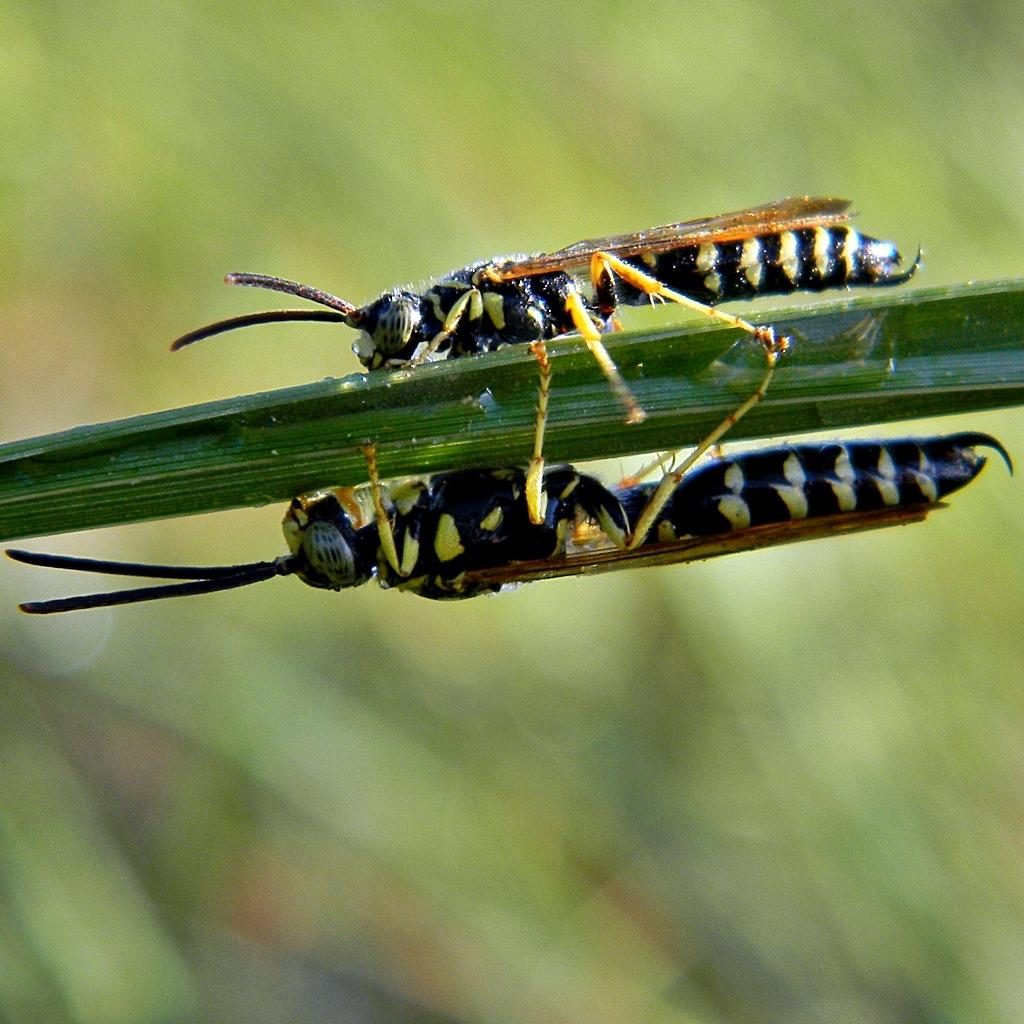What is the main subject of the image? There is a grasshopper in the image. Can you describe the background of the image? The background of the image is blurred. What else can be seen in the blurred background? There is a reflection visible in the blurred background. What type of theory is being discussed in the image? There is no discussion or theory present in the image; it features a grasshopper and a blurred background with a reflection. 